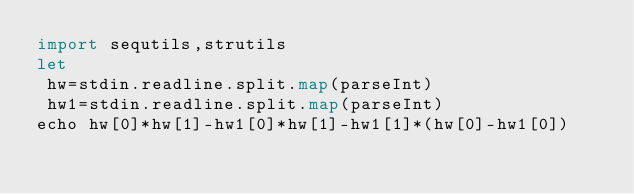Convert code to text. <code><loc_0><loc_0><loc_500><loc_500><_Nim_>import sequtils,strutils
let
 hw=stdin.readline.split.map(parseInt)
 hw1=stdin.readline.split.map(parseInt)
echo hw[0]*hw[1]-hw1[0]*hw[1]-hw1[1]*(hw[0]-hw1[0])</code> 